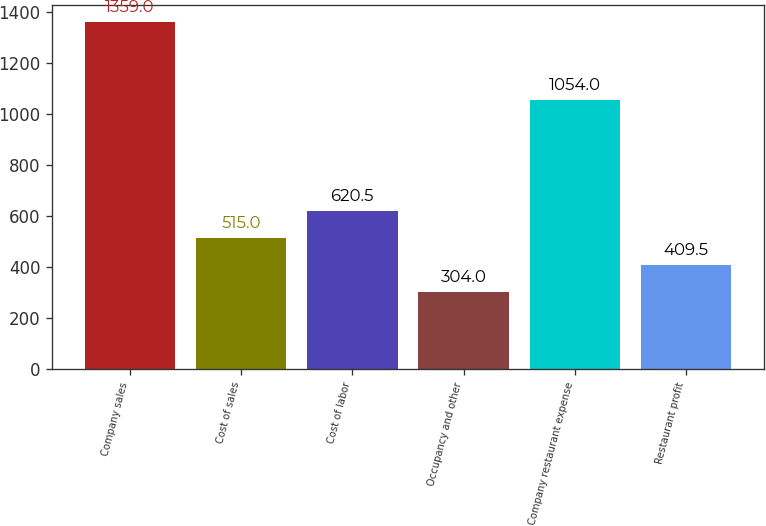Convert chart to OTSL. <chart><loc_0><loc_0><loc_500><loc_500><bar_chart><fcel>Company sales<fcel>Cost of sales<fcel>Cost of labor<fcel>Occupancy and other<fcel>Company restaurant expense<fcel>Restaurant profit<nl><fcel>1359<fcel>515<fcel>620.5<fcel>304<fcel>1054<fcel>409.5<nl></chart> 